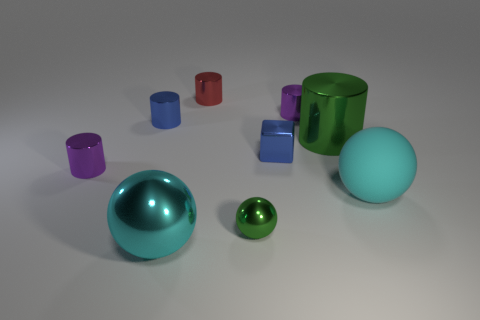Is the color of the block the same as the rubber sphere on the right side of the small red object?
Provide a succinct answer. No. Are there more small purple cylinders behind the blue shiny cylinder than big cyan things?
Ensure brevity in your answer.  No. There is a big shiny object behind the purple object that is on the left side of the red object; how many small blue things are in front of it?
Your answer should be very brief. 1. Do the big metal object to the left of the red cylinder and the tiny green metallic thing have the same shape?
Ensure brevity in your answer.  Yes. What is the material of the small cylinder in front of the blue cube?
Give a very brief answer. Metal. What shape is the shiny thing that is in front of the blue cylinder and behind the tiny metallic cube?
Offer a very short reply. Cylinder. Is the number of cyan balls the same as the number of objects?
Ensure brevity in your answer.  No. What material is the small green sphere?
Make the answer very short. Metal. How many blocks are either big green objects or blue metallic things?
Provide a succinct answer. 1. Does the small red object have the same material as the tiny green ball?
Ensure brevity in your answer.  Yes. 